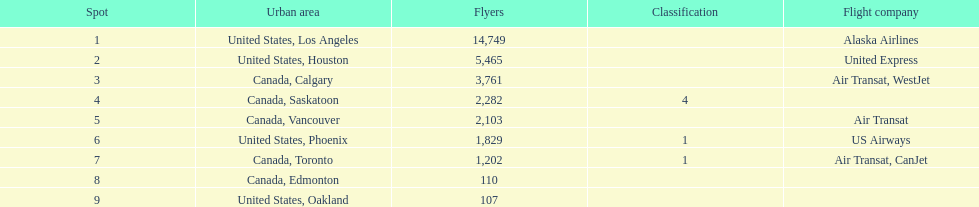Los angeles and what other city had about 19,000 passenger combined Canada, Calgary. 